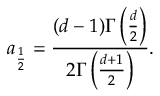<formula> <loc_0><loc_0><loc_500><loc_500>a _ { \frac { 1 } { 2 } } = \frac { ( d - 1 ) \Gamma \left ( \frac { d } 2 \right ) } { 2 \Gamma \left ( \frac { d + 1 } 2 \right ) } .</formula> 